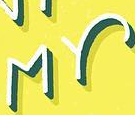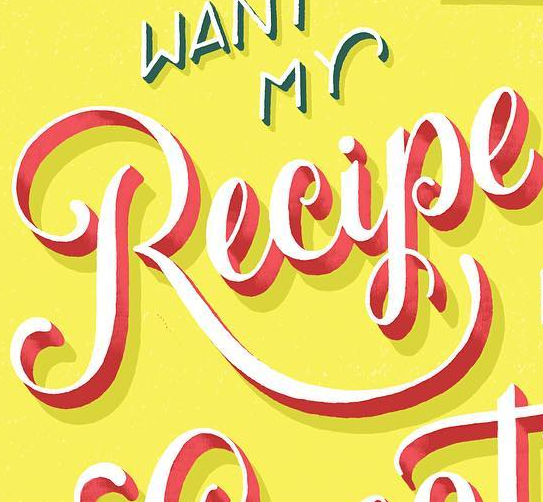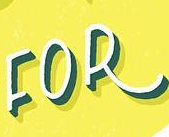Read the text from these images in sequence, separated by a semicolon. MY; Recipe; FOR 